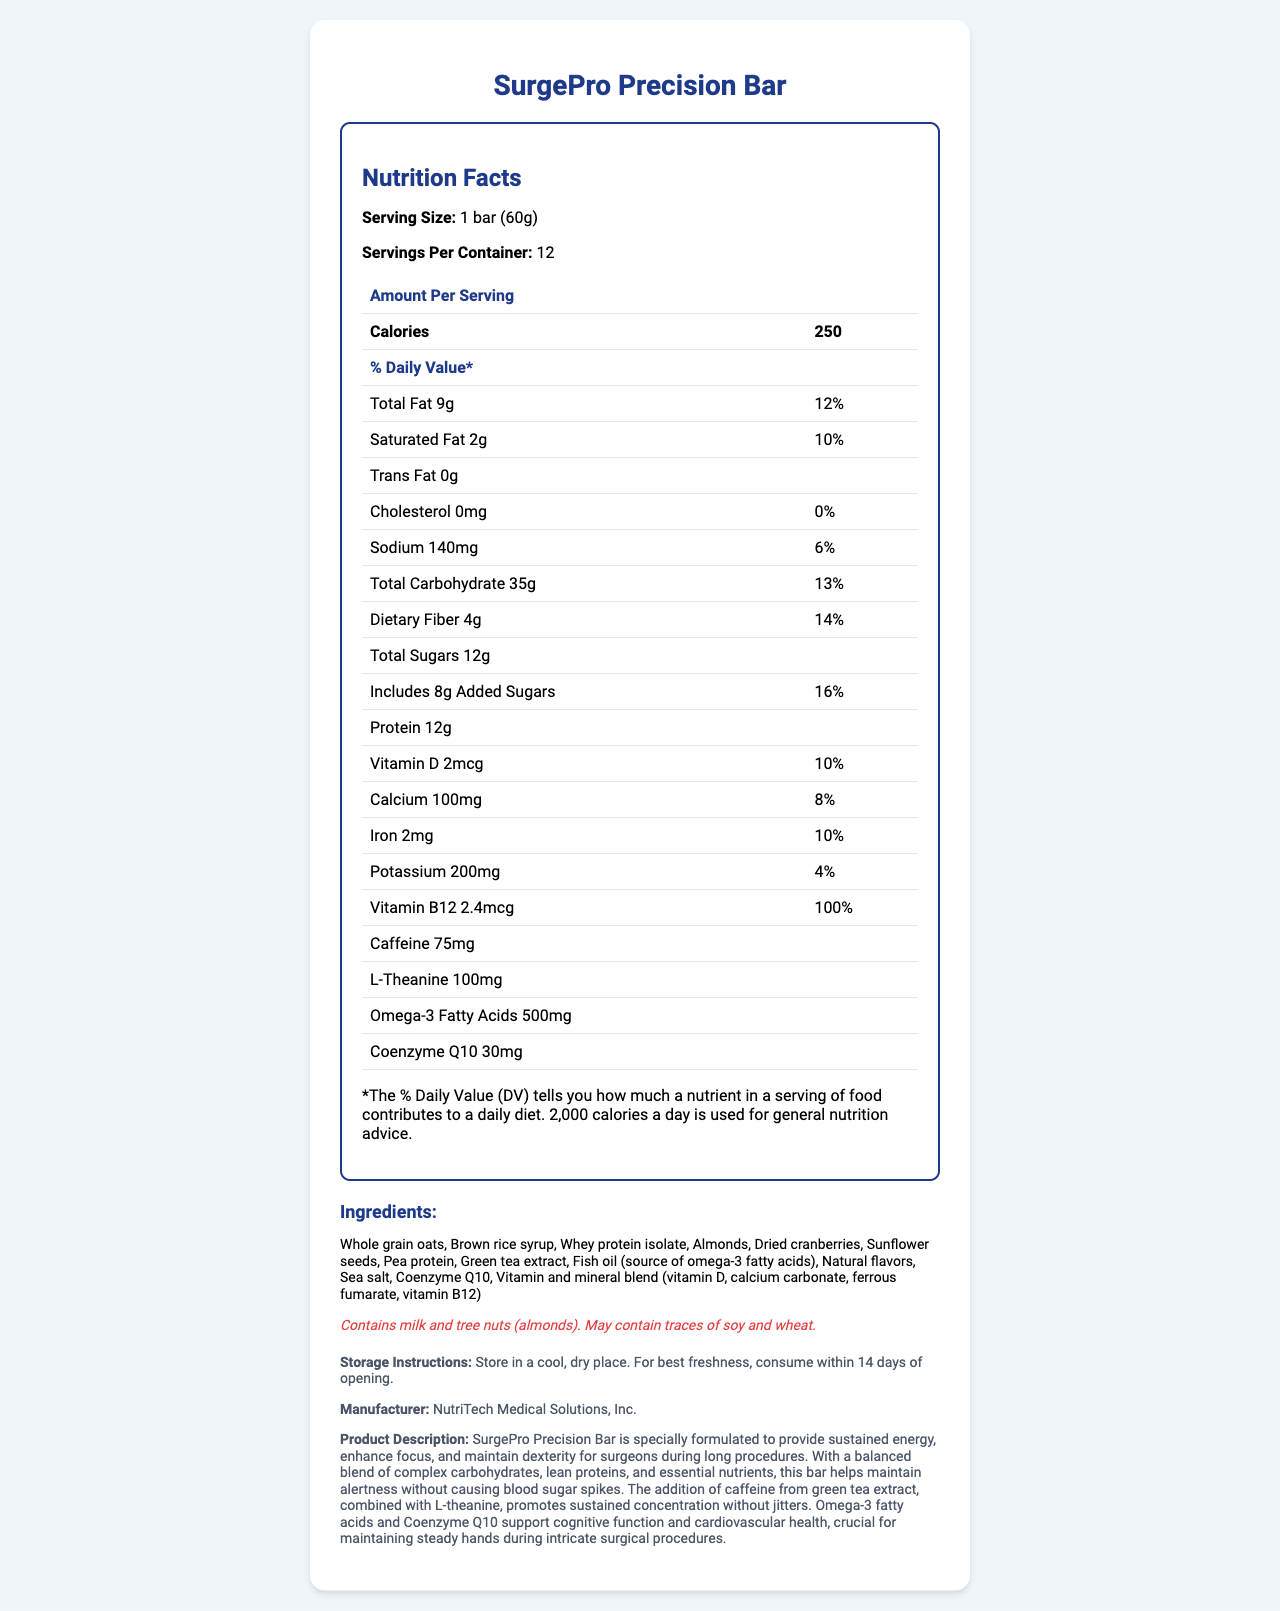what is the serving size? The serving size is clearly listed in the Nutrition Facts section as "1 bar (60g)".
Answer: 1 bar (60g) how many calories are in one SurgePro Precision Bar? The Nutrition Facts table lists the amount of calories per serving as 250.
Answer: 250 what is the amount of protein in one bar? The document specifies that the protein content per serving is 12g.
Answer: 12g what is the percentage of the daily value of vitamin D in one bar? The percentage daily value of vitamin D is noted as 10%.
Answer: 10% which ingredients might cause allergies? The allergen information mentions milk and tree nuts (almonds) as well as potential traces of soy and wheat.
Answer: Milk and tree nuts (almonds), and may contain traces of soy and wheat how many servings are there per container of SurgePro Precision Bars? The number of servings per container is listed as 12.
Answer: 12 what is the amount of added sugars in one serving? A. 6g B. 8g C. 10g D. 12g The Nutrition Facts state that the added sugars amount to 8g per serving.
Answer: B. 8g which mineral has the highest daily value percentage in one bar? I. Calcium II. Iron III. Potassium IV. Sodium Iron has the highest daily value percentage at 10%, compared to Calcium (8%), Potassium (4%), and Sodium (6%).
Answer: II. Iron does the SurgePro Precision Bar contain any trans fat? The document states that there is 0g trans fat in the bar.
Answer: No does the SurgePro Precision Bar contain caffeine? The Nutrition Facts indicate that one bar contains 75mg of caffeine.
Answer: Yes what should you do to maintain freshness after opening a SurgePro Precision Bar? The storage instructions clearly stipulate storing in a cool, dry place and consuming within 14 days of opening for best freshness.
Answer: Consume within 14 days and store in a cool, dry place what is the overall purpose of the SurgePro Precision Bar, according to the product description? The description explains that the bar is specially formulated to aid surgeons in maintaining energy, focus, and dexterity during extended surgeries.
Answer: To provide sustained energy, enhance focus, and maintain dexterity for surgeons during long procedures how much L-Theanine is in one bar? The Nutrition Facts list 100mg of L-Theanine per bar.
Answer: 100mg describe the main idea of this document. The document outlines the nutritional content, ingredients, allergen information, storage instructions, manufacturer details, and a product description emphasizing the bar's role in supporting surgeons' energy and cognitive function.
Answer: The document provides detailed nutritional information, ingredients, and the specific benefits of the SurgePro Precision Bar, which is formulated to help surgeons maintain alertness and dexterity during long surgical procedures. what is the daily value percentage of omega-3 fatty acids in one bar? The document does not provide a daily value percentage for omega-3 fatty acids.
Answer: Not available 